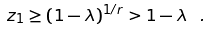<formula> <loc_0><loc_0><loc_500><loc_500>z _ { 1 } \geq ( 1 - \lambda ) ^ { 1 / r } > 1 - \lambda \ .</formula> 